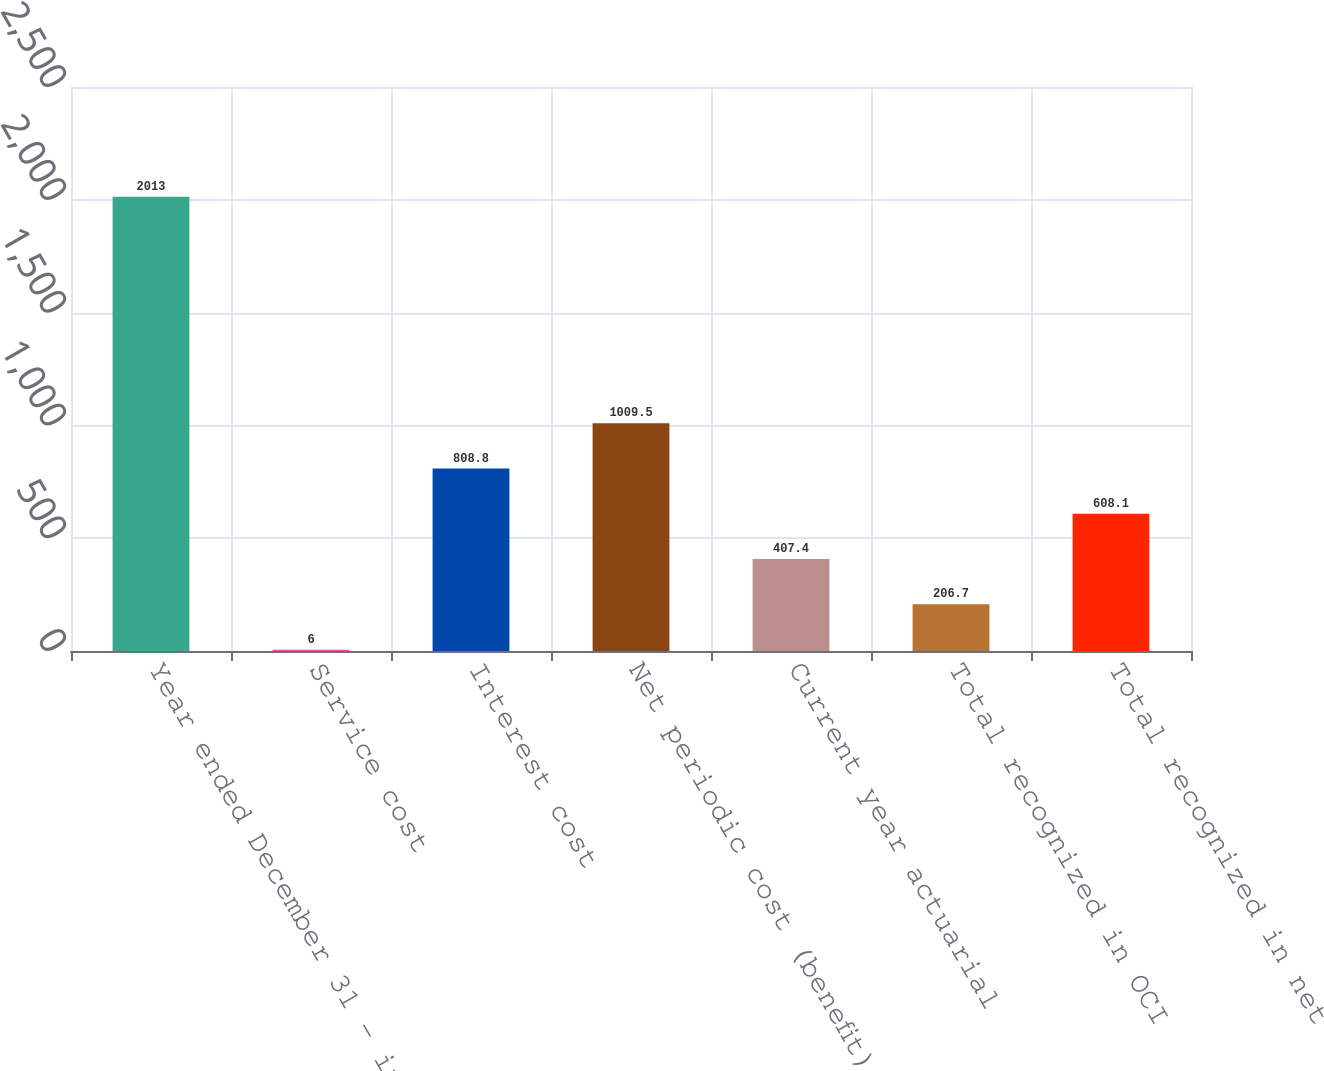Convert chart to OTSL. <chart><loc_0><loc_0><loc_500><loc_500><bar_chart><fcel>Year ended December 31 - in<fcel>Service cost<fcel>Interest cost<fcel>Net periodic cost (benefit)<fcel>Current year actuarial<fcel>Total recognized in OCI<fcel>Total recognized in net<nl><fcel>2013<fcel>6<fcel>808.8<fcel>1009.5<fcel>407.4<fcel>206.7<fcel>608.1<nl></chart> 